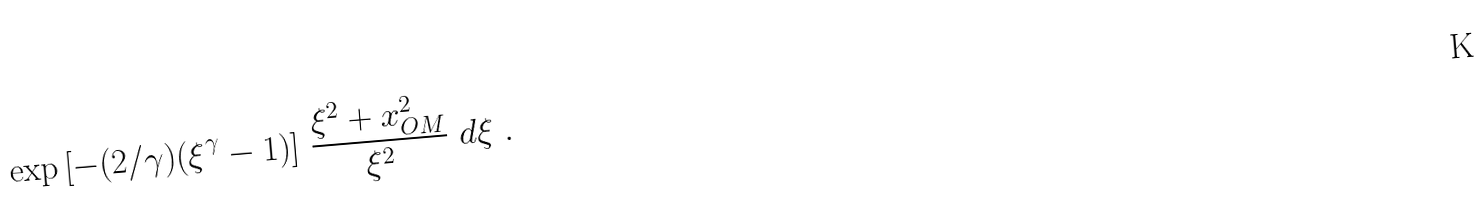<formula> <loc_0><loc_0><loc_500><loc_500>\quad \exp { \left [ - ( 2 / \gamma ) ( \xi ^ { \gamma } - 1 ) \right ] } \ \frac { \xi ^ { 2 } + x _ { O M } ^ { 2 } } { \xi ^ { 2 } } \ d \xi \ .</formula> 